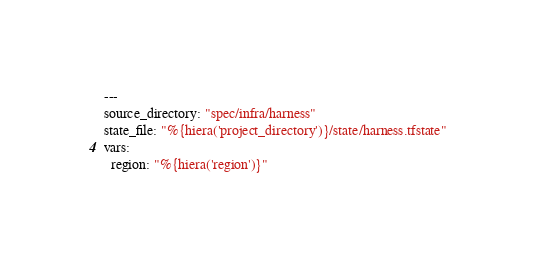Convert code to text. <code><loc_0><loc_0><loc_500><loc_500><_YAML_>---
source_directory: "spec/infra/harness"
state_file: "%{hiera('project_directory')}/state/harness.tfstate"
vars:
  region: "%{hiera('region')}"
</code> 